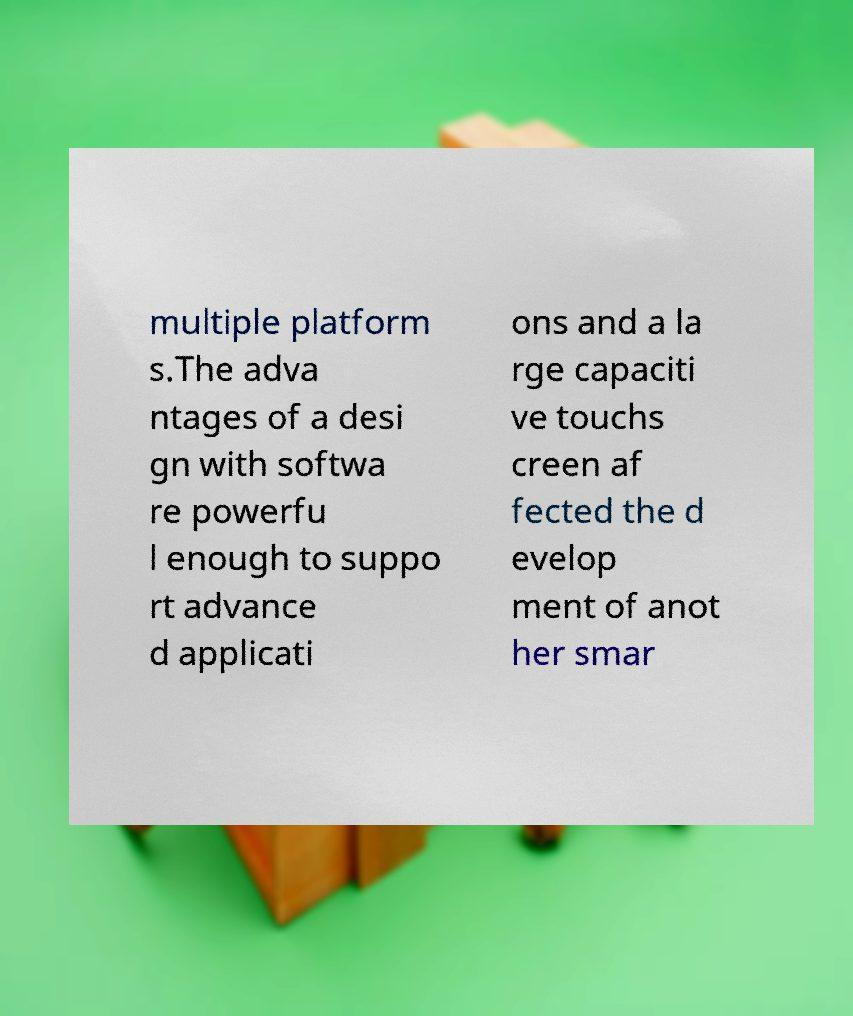Could you assist in decoding the text presented in this image and type it out clearly? multiple platform s.The adva ntages of a desi gn with softwa re powerfu l enough to suppo rt advance d applicati ons and a la rge capaciti ve touchs creen af fected the d evelop ment of anot her smar 